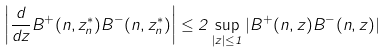Convert formula to latex. <formula><loc_0><loc_0><loc_500><loc_500>\left | \frac { d } { d z } B ^ { + } ( n , z _ { n } ^ { * } ) B ^ { - } ( n , z _ { n } ^ { * } ) \right | \leq 2 \sup _ { | z | \leq 1 } | B ^ { + } ( n , z ) B ^ { - } ( n , z ) |</formula> 